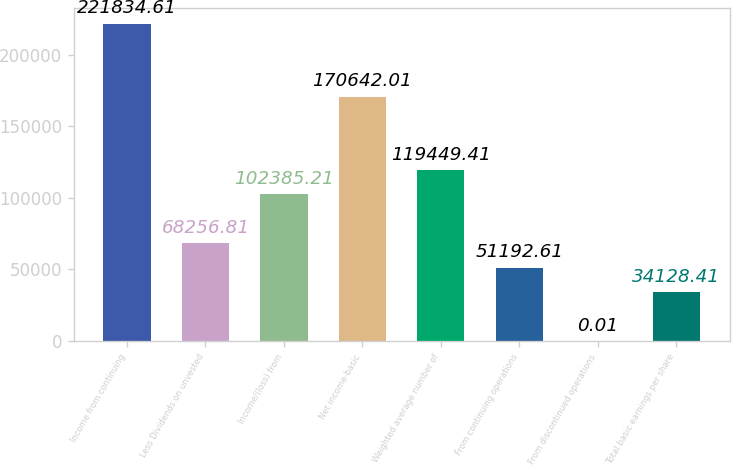Convert chart to OTSL. <chart><loc_0><loc_0><loc_500><loc_500><bar_chart><fcel>Income from continuing<fcel>Less Dividends on unvested<fcel>Income/(loss) from<fcel>Net income-basic<fcel>Weighted average number of<fcel>From continuing operations<fcel>From discontinued operations<fcel>Total basic earnings per share<nl><fcel>221835<fcel>68256.8<fcel>102385<fcel>170642<fcel>119449<fcel>51192.6<fcel>0.01<fcel>34128.4<nl></chart> 